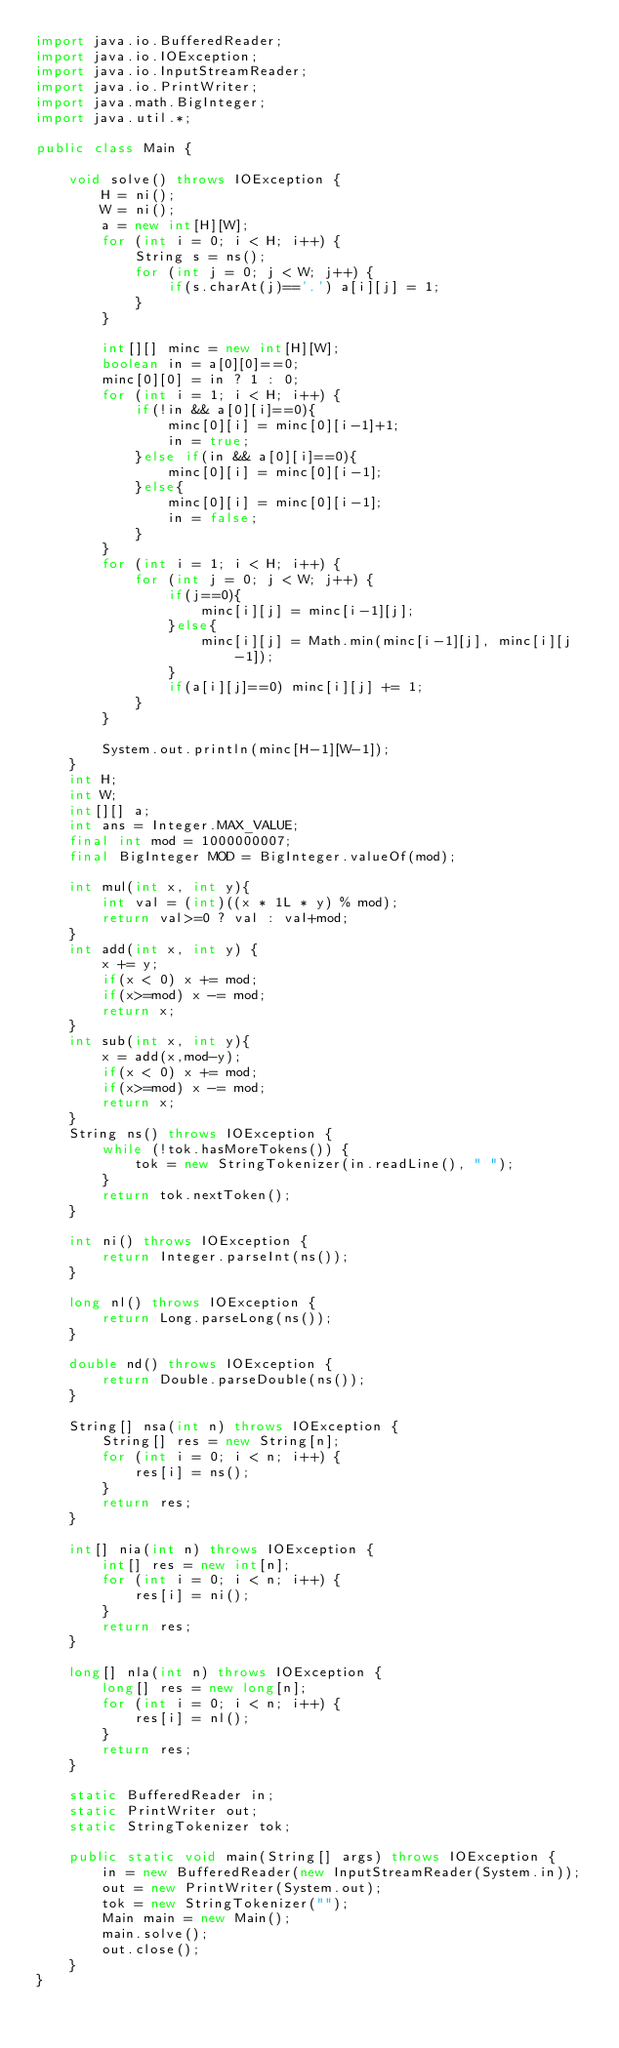Convert code to text. <code><loc_0><loc_0><loc_500><loc_500><_Java_>import java.io.BufferedReader;
import java.io.IOException;
import java.io.InputStreamReader;
import java.io.PrintWriter;
import java.math.BigInteger;
import java.util.*;
 
public class Main {
 
    void solve() throws IOException {
        H = ni();
        W = ni();
        a = new int[H][W];
        for (int i = 0; i < H; i++) {
            String s = ns();
            for (int j = 0; j < W; j++) {
                if(s.charAt(j)=='.') a[i][j] = 1;
            }
        } 

        int[][] minc = new int[H][W];
        boolean in = a[0][0]==0;
        minc[0][0] = in ? 1 : 0;
        for (int i = 1; i < H; i++) {
            if(!in && a[0][i]==0){
                minc[0][i] = minc[0][i-1]+1; 
                in = true;
            }else if(in && a[0][i]==0){
                minc[0][i] = minc[0][i-1];
            }else{
                minc[0][i] = minc[0][i-1];
                in = false;
            }
        }
        for (int i = 1; i < H; i++) {
            for (int j = 0; j < W; j++) {
                if(j==0){
                    minc[i][j] = minc[i-1][j];
                }else{
                    minc[i][j] = Math.min(minc[i-1][j], minc[i][j-1]);
                }
                if(a[i][j]==0) minc[i][j] += 1;
            }
        }

        System.out.println(minc[H-1][W-1]);
    }
    int H;
    int W;
    int[][] a;
    int ans = Integer.MAX_VALUE;
    final int mod = 1000000007;
    final BigInteger MOD = BigInteger.valueOf(mod);

    int mul(int x, int y){
        int val = (int)((x * 1L * y) % mod);
        return val>=0 ? val : val+mod;
    }
    int add(int x, int y) {
        x += y;
        if(x < 0) x += mod;
        if(x>=mod) x -= mod;
        return x;
    }
    int sub(int x, int y){
        x = add(x,mod-y);
        if(x < 0) x += mod;
        if(x>=mod) x -= mod;
        return x;
    }
    String ns() throws IOException {
        while (!tok.hasMoreTokens()) {
            tok = new StringTokenizer(in.readLine(), " ");
        }
        return tok.nextToken();
    }
 
    int ni() throws IOException {
        return Integer.parseInt(ns());
    }
 
    long nl() throws IOException {
        return Long.parseLong(ns());
    }
 
    double nd() throws IOException {
        return Double.parseDouble(ns());
    }
 
    String[] nsa(int n) throws IOException {
        String[] res = new String[n];
        for (int i = 0; i < n; i++) {
            res[i] = ns();
        }
        return res;
    }
 
    int[] nia(int n) throws IOException {
        int[] res = new int[n];
        for (int i = 0; i < n; i++) {
            res[i] = ni();
        }
        return res;
    }
 
    long[] nla(int n) throws IOException {
        long[] res = new long[n];
        for (int i = 0; i < n; i++) {
            res[i] = nl();
        }
        return res;
    }
 
    static BufferedReader in;
    static PrintWriter out;
    static StringTokenizer tok;
 
    public static void main(String[] args) throws IOException {
        in = new BufferedReader(new InputStreamReader(System.in));
        out = new PrintWriter(System.out);
        tok = new StringTokenizer("");
        Main main = new Main();
        main.solve();
        out.close();
    }
}</code> 